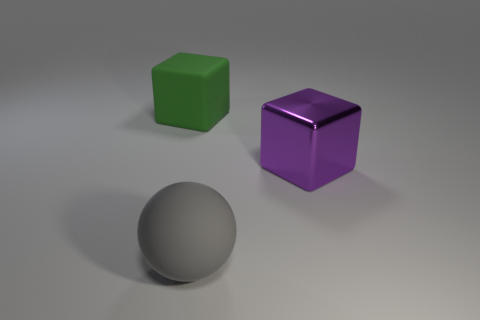Subtract 1 balls. How many balls are left? 0 Add 2 big matte objects. How many objects exist? 5 Subtract all balls. How many objects are left? 2 Subtract 0 red spheres. How many objects are left? 3 Subtract all purple blocks. Subtract all red balls. How many blocks are left? 1 Subtract all yellow spheres. How many green cubes are left? 1 Subtract all tiny metallic balls. Subtract all matte things. How many objects are left? 1 Add 2 big gray balls. How many big gray balls are left? 3 Add 3 big rubber things. How many big rubber things exist? 5 